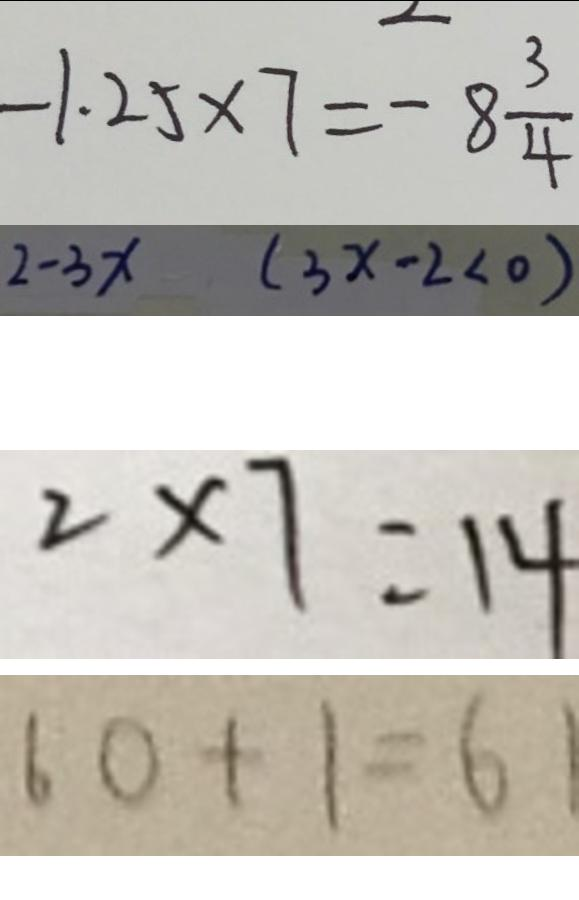<formula> <loc_0><loc_0><loc_500><loc_500>- 1 . 2 5 \times 7 = - 8 \frac { 3 } { 4 } 
 2 - 3 x ( 3 x - 2 < 0 ) 
 2 \times 7 = 1 4 
 6 0 + 1 = 6 1</formula> 